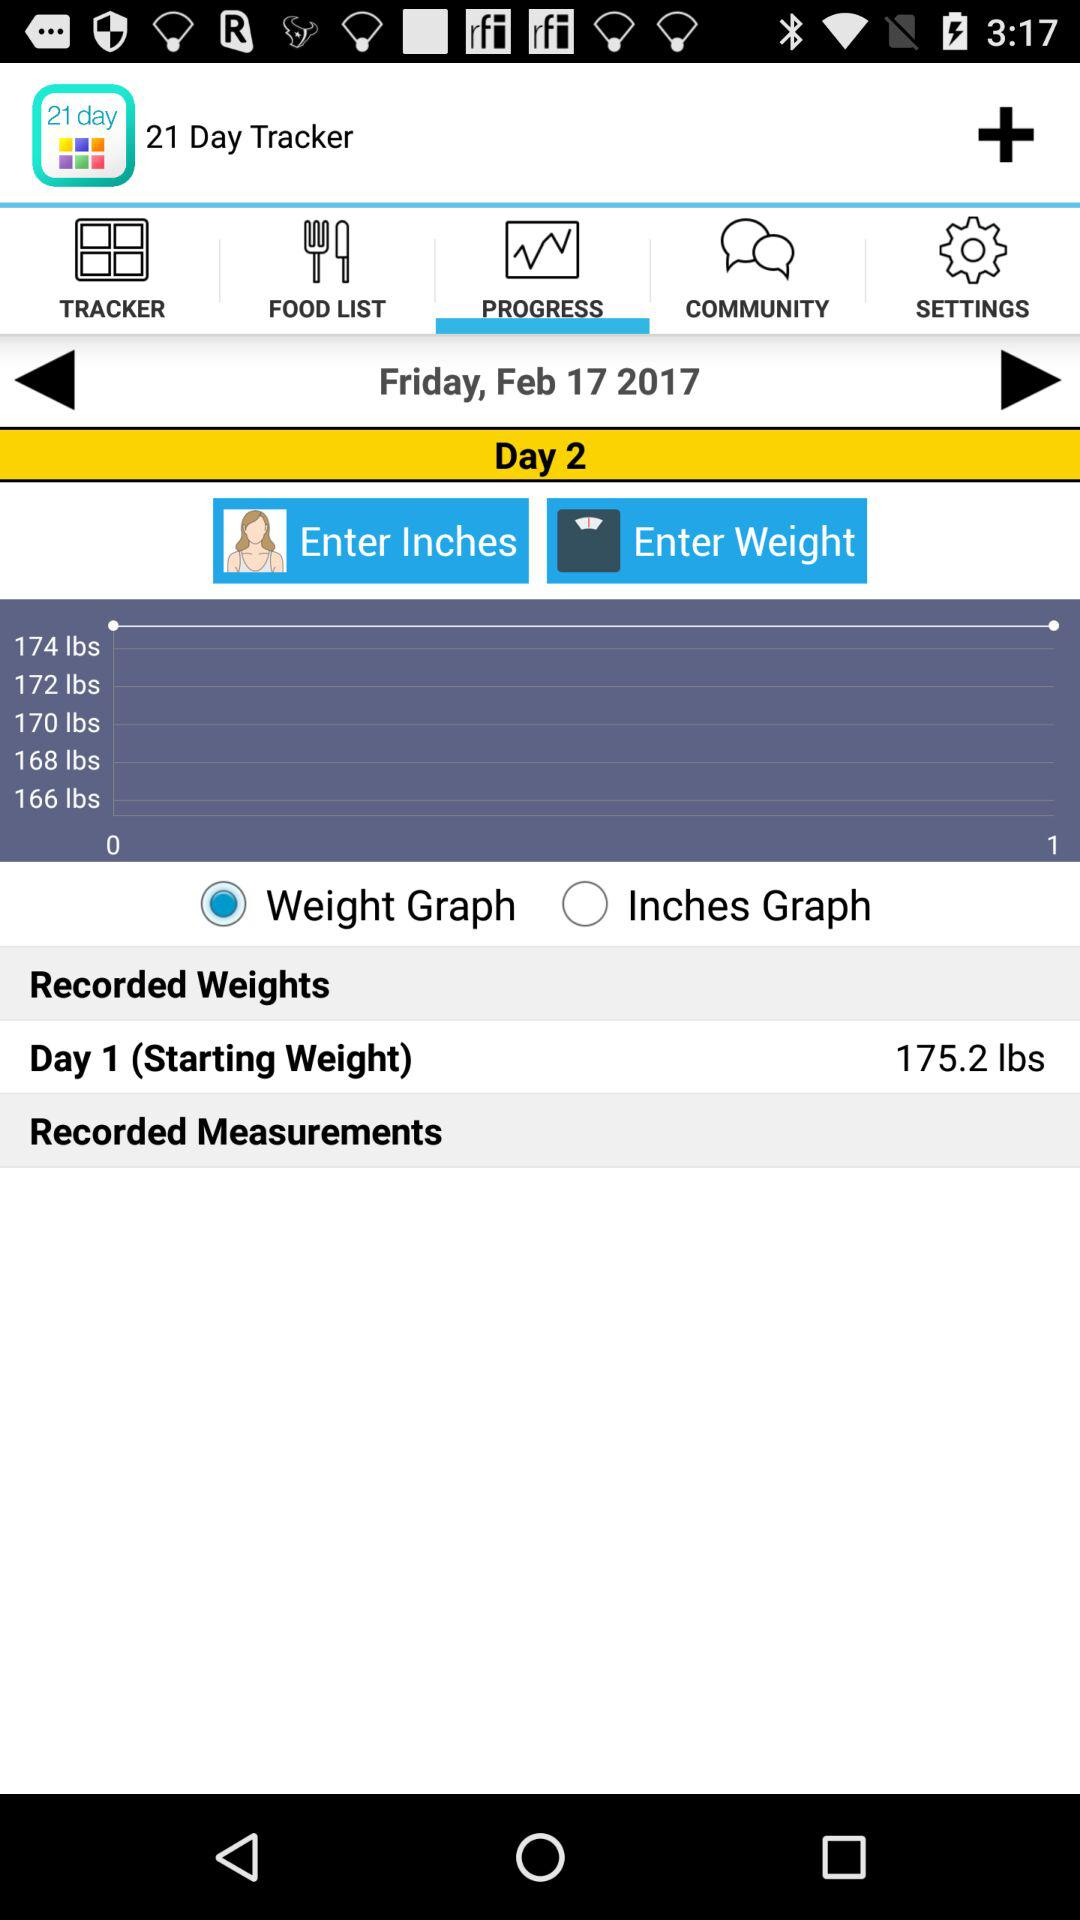What is the starting weight? The starting weight is 175.2 lbs. 